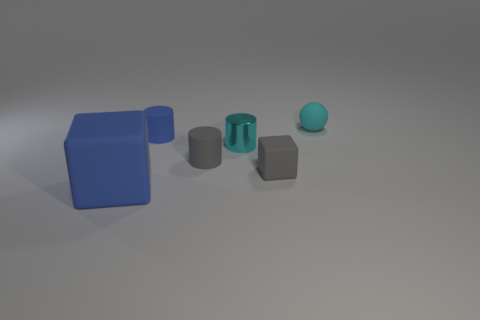Add 4 cyan metallic things. How many objects exist? 10 Subtract all tiny cyan shiny cylinders. How many cylinders are left? 2 Subtract all spheres. How many objects are left? 5 Subtract all gray cylinders. How many cylinders are left? 2 Subtract 0 green cylinders. How many objects are left? 6 Subtract 1 spheres. How many spheres are left? 0 Subtract all yellow spheres. Subtract all purple cylinders. How many spheres are left? 1 Subtract all red cubes. How many red balls are left? 0 Subtract all big yellow cubes. Subtract all tiny cyan cylinders. How many objects are left? 5 Add 1 small rubber blocks. How many small rubber blocks are left? 2 